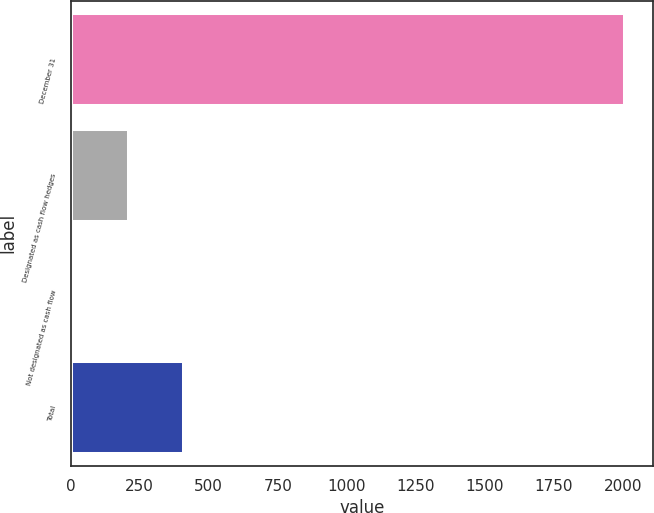<chart> <loc_0><loc_0><loc_500><loc_500><bar_chart><fcel>December 31<fcel>Designated as cash flow hedges<fcel>Not designated as cash flow<fcel>Total<nl><fcel>2008<fcel>211.6<fcel>12<fcel>411.2<nl></chart> 